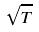<formula> <loc_0><loc_0><loc_500><loc_500>\sqrt { T }</formula> 